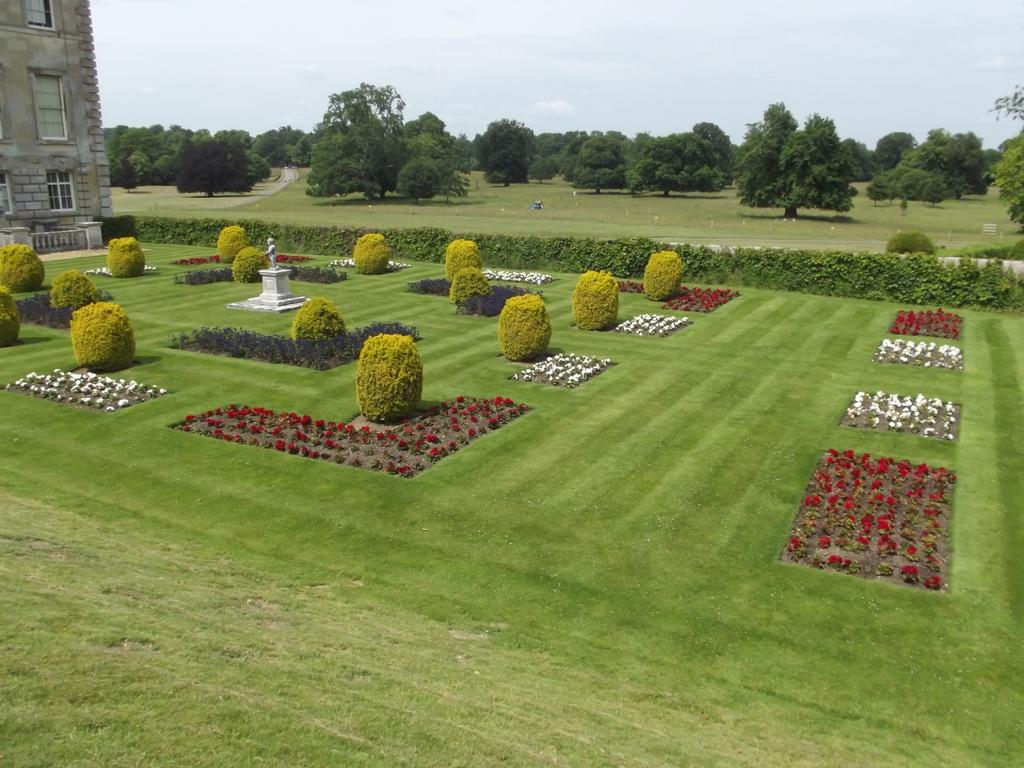What type of vegetation can be seen at the bottom of the image? There are bushes and hedges at the bottom of the image. What is located on the left side of the image? There is a statue and a building on the left side of the image. What type of plants are present in the image? Flower plants are present in the image. What can be seen in the background of the image? There are trees and the sky visible in the background of the image. What year is the statue commemorating in the image? There is no information about the year or any commemoration related to the statue in the image. Can you see the tongue of the statue in the image? There is no tongue visible on the statue in the image. 